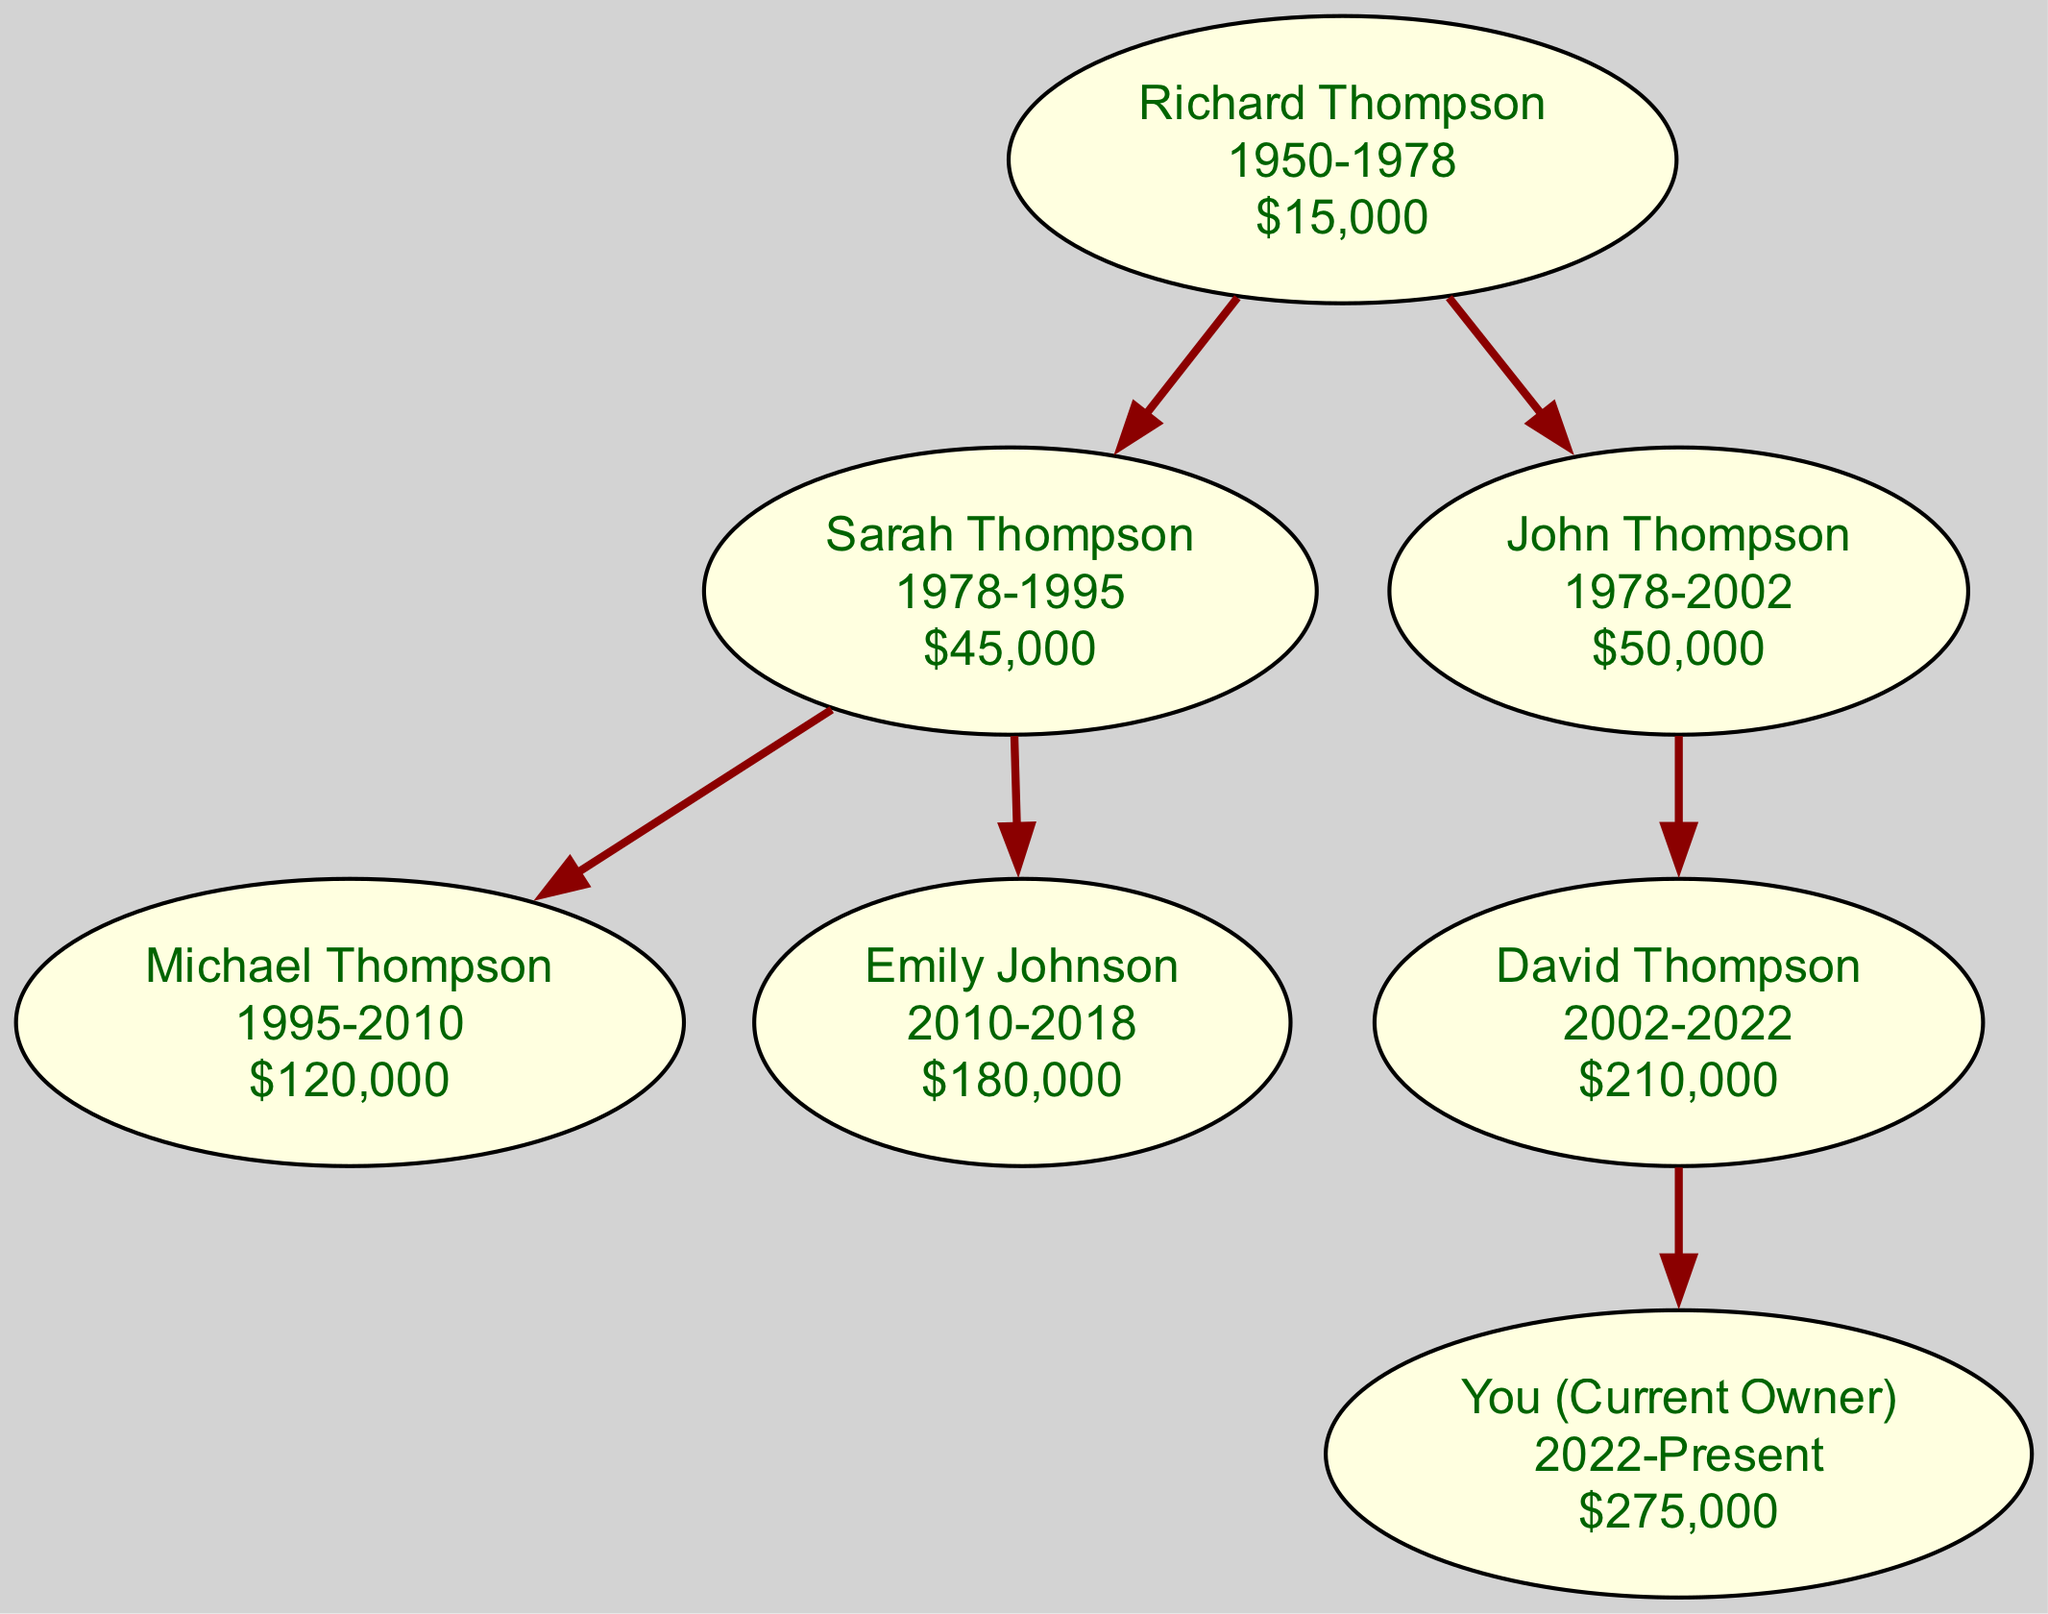What is the total number of owners listed in the diagram? The diagram outlines a lineage of property ownership starting from Richard Thompson, through Sarah, John, Michael, Emily, and David, leading to the current owner, thus counting seven individual owners in total.
Answer: 7 Who owned the property just before you? The diagram indicates that you acquired the property in 2022; the last listed owner before you is David Thompson, who owned it until 2022.
Answer: David Thompson What was the sale price of the property when Richard Thompson sold it? Richard Thompson sold the property for $15,000, as indicated in his node on the diagram, clearly stated next to his ownership period.
Answer: $15,000 How long did Sarah Thompson own the property? Sarah Thompson’s ownership period spans from 1978 to 1995, which constitutes a total of 17 years.
Answer: 17 years Which owner had the highest sale price before the current ownership? Analyzing the sale prices, Michael Thompson sold the property for $120,000, which is the highest sale price noted before the current ownership by you.
Answer: $120,000 What is the relationship between John and Richard Thompson? John Thompson is a child of Richard Thompson, as shown in the family tree structure; John is listed under Richard's node, indicating a parent-child relationship.
Answer: Child What was the ownership period of Emily Johnson? Emily Johnson owned the property from 2010 to 2018, which is an ownership span of 8 years.
Answer: 8 years How many children did Sarah Thompson have? The diagram reveals that Sarah Thompson had two children, Michael Thompson and Emily Johnson, both represented as subordinate nodes under her node.
Answer: 2 What was the total increase in sale price from Richard Thompson to you? Calculating the increase involves taking the initial sale price of $15,000 from Richard and subtracting it from your current value of $275,000, yielding an increase of $260,000.
Answer: $260,000 